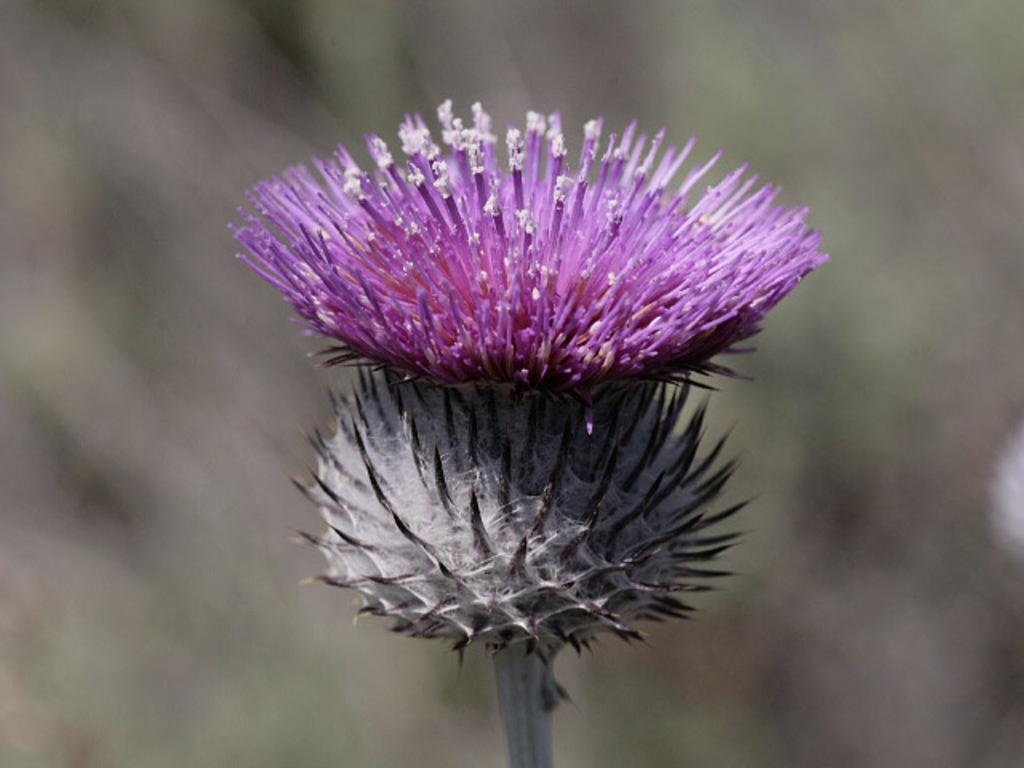What is the main subject of the image? There is a flower in the image. Can you describe the colors of the flower? The flower has pink, white, and black colors. How would you describe the background of the image? The background of the image is blurry. In which direction is the truck moving in the image? There is no truck present in the image, so it is not possible to determine the direction of movement. 